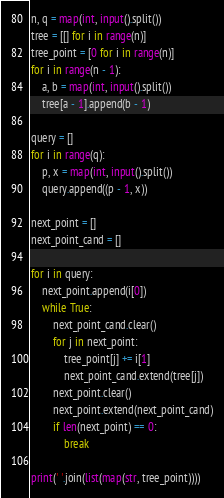Convert code to text. <code><loc_0><loc_0><loc_500><loc_500><_Python_>n, q = map(int, input().split())
tree = [[] for i in range(n)]
tree_point = [0 for i in range(n)]
for i in range(n - 1):
    a, b = map(int, input().split())
    tree[a - 1].append(b - 1)

query = []
for i in range(q):
    p, x = map(int, input().split())
    query.append((p - 1, x))

next_point = []
next_point_cand = []

for i in query:
    next_point.append(i[0])
    while True:
        next_point_cand.clear()
        for j in next_point:
            tree_point[j] += i[1]
            next_point_cand.extend(tree[j])
        next_point.clear()
        next_point.extend(next_point_cand)
        if len(next_point) == 0:
            break

print(' '.join(list(map(str, tree_point)))) 
</code> 